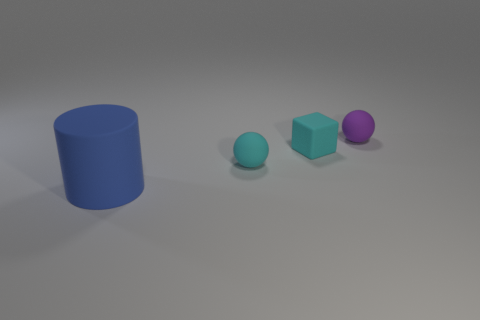There is a cyan matte object that is behind the cyan ball; is its size the same as the small purple rubber thing?
Keep it short and to the point. Yes. What number of things are tiny cyan matte spheres or large matte cylinders?
Offer a very short reply. 2. There is a ball that is right of the small matte sphere that is in front of the small cyan matte thing behind the small cyan rubber ball; what is it made of?
Offer a terse response. Rubber. There is a thing that is in front of the small cyan sphere; what is it made of?
Give a very brief answer. Rubber. Is there a matte ball of the same size as the block?
Offer a terse response. Yes. There is a matte ball that is in front of the purple matte thing; does it have the same color as the large cylinder?
Ensure brevity in your answer.  No. How many cyan objects are either tiny cubes or large rubber cylinders?
Your answer should be compact. 1. What number of rubber balls have the same color as the tiny block?
Give a very brief answer. 1. What number of tiny rubber spheres are left of the small cyan matte object that is right of the cyan rubber sphere?
Offer a very short reply. 1. Is the size of the blue cylinder the same as the cyan cube?
Your answer should be compact. No. 